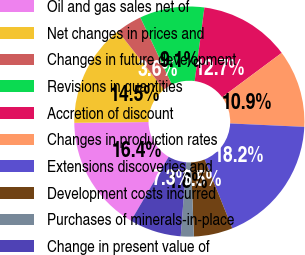Convert chart to OTSL. <chart><loc_0><loc_0><loc_500><loc_500><pie_chart><fcel>Oil and gas sales net of<fcel>Net changes in prices and<fcel>Changes in future development<fcel>Revisions in quantities<fcel>Accretion of discount<fcel>Changes in production rates<fcel>Extensions discoveries and<fcel>Development costs incurred<fcel>Purchases of minerals-in-place<fcel>Change in present value of<nl><fcel>16.36%<fcel>14.54%<fcel>3.64%<fcel>9.09%<fcel>12.73%<fcel>10.91%<fcel>18.18%<fcel>5.46%<fcel>1.82%<fcel>7.27%<nl></chart> 